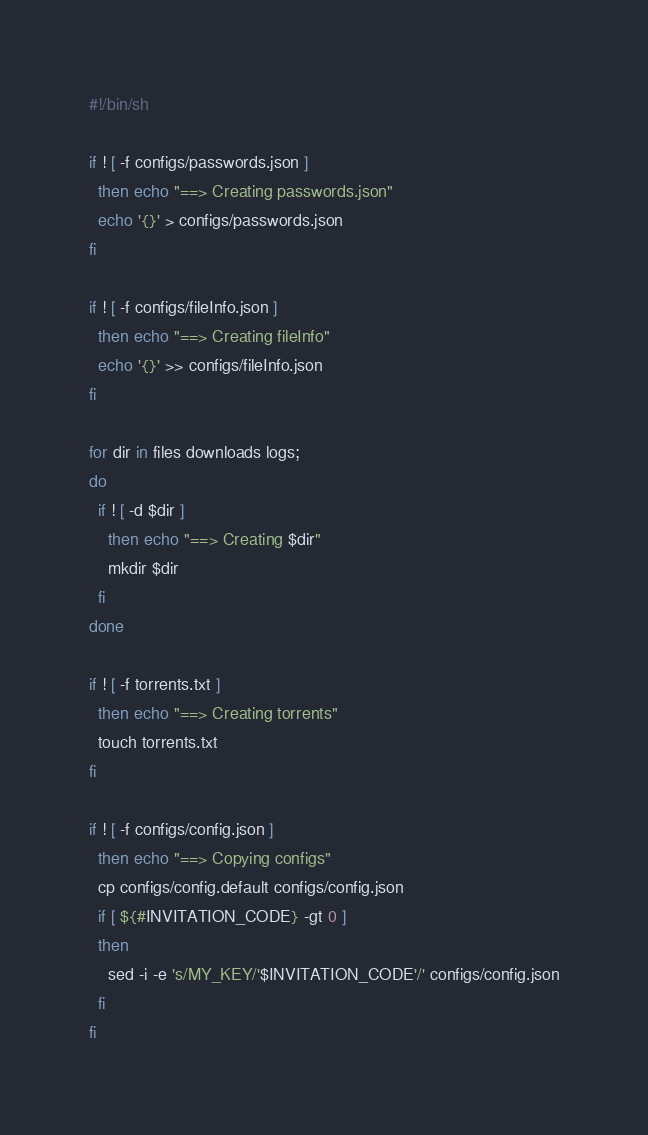<code> <loc_0><loc_0><loc_500><loc_500><_Bash_>#!/bin/sh

if ! [ -f configs/passwords.json ]
  then echo "==> Creating passwords.json"
  echo '{}' > configs/passwords.json
fi

if ! [ -f configs/fileInfo.json ]
  then echo "==> Creating fileInfo"
  echo '{}' >> configs/fileInfo.json
fi

for dir in files downloads logs;
do
  if ! [ -d $dir ]
    then echo "==> Creating $dir"
    mkdir $dir
  fi
done

if ! [ -f torrents.txt ]
  then echo "==> Creating torrents"
  touch torrents.txt
fi

if ! [ -f configs/config.json ]
  then echo "==> Copying configs"
  cp configs/config.default configs/config.json
  if [ ${#INVITATION_CODE} -gt 0 ]
  then
    sed -i -e 's/MY_KEY/'$INVITATION_CODE'/' configs/config.json
  fi
fi
</code> 